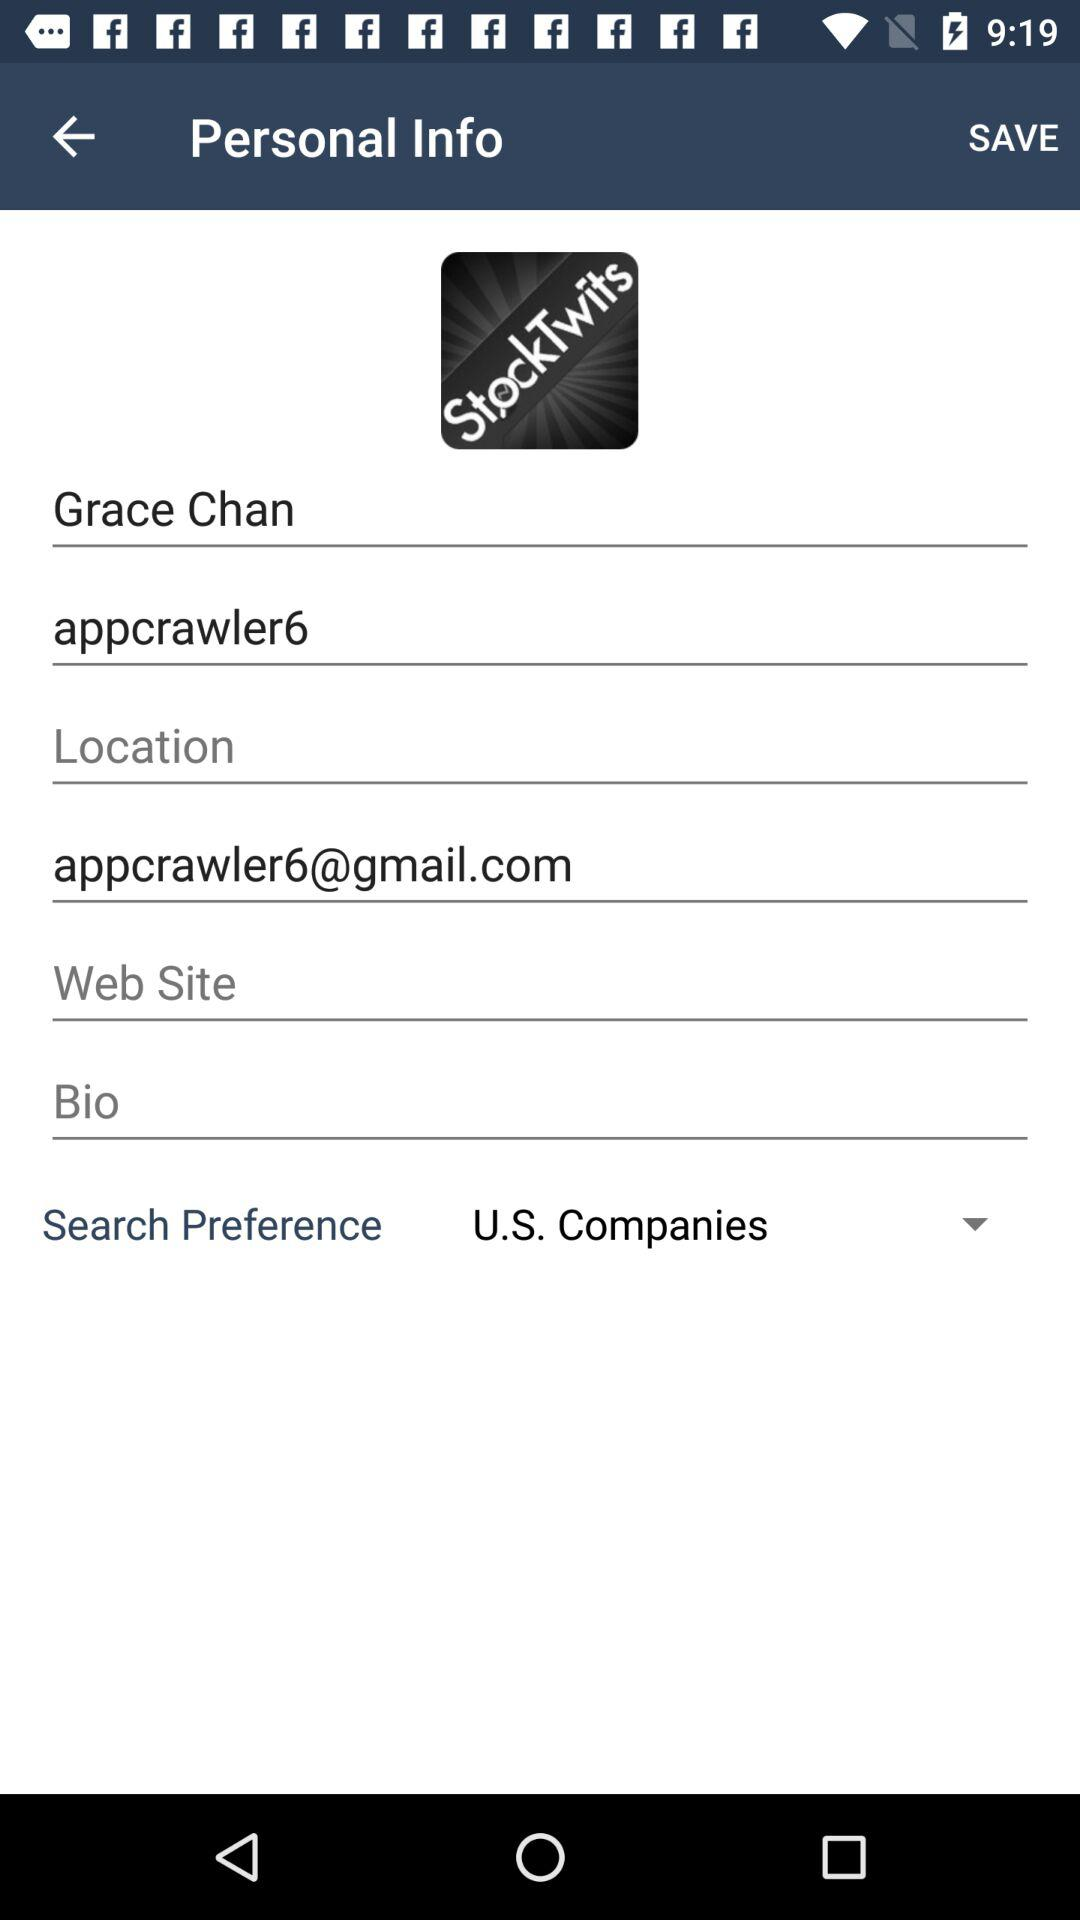What is the search preference? The search preference is U.S. companies. 